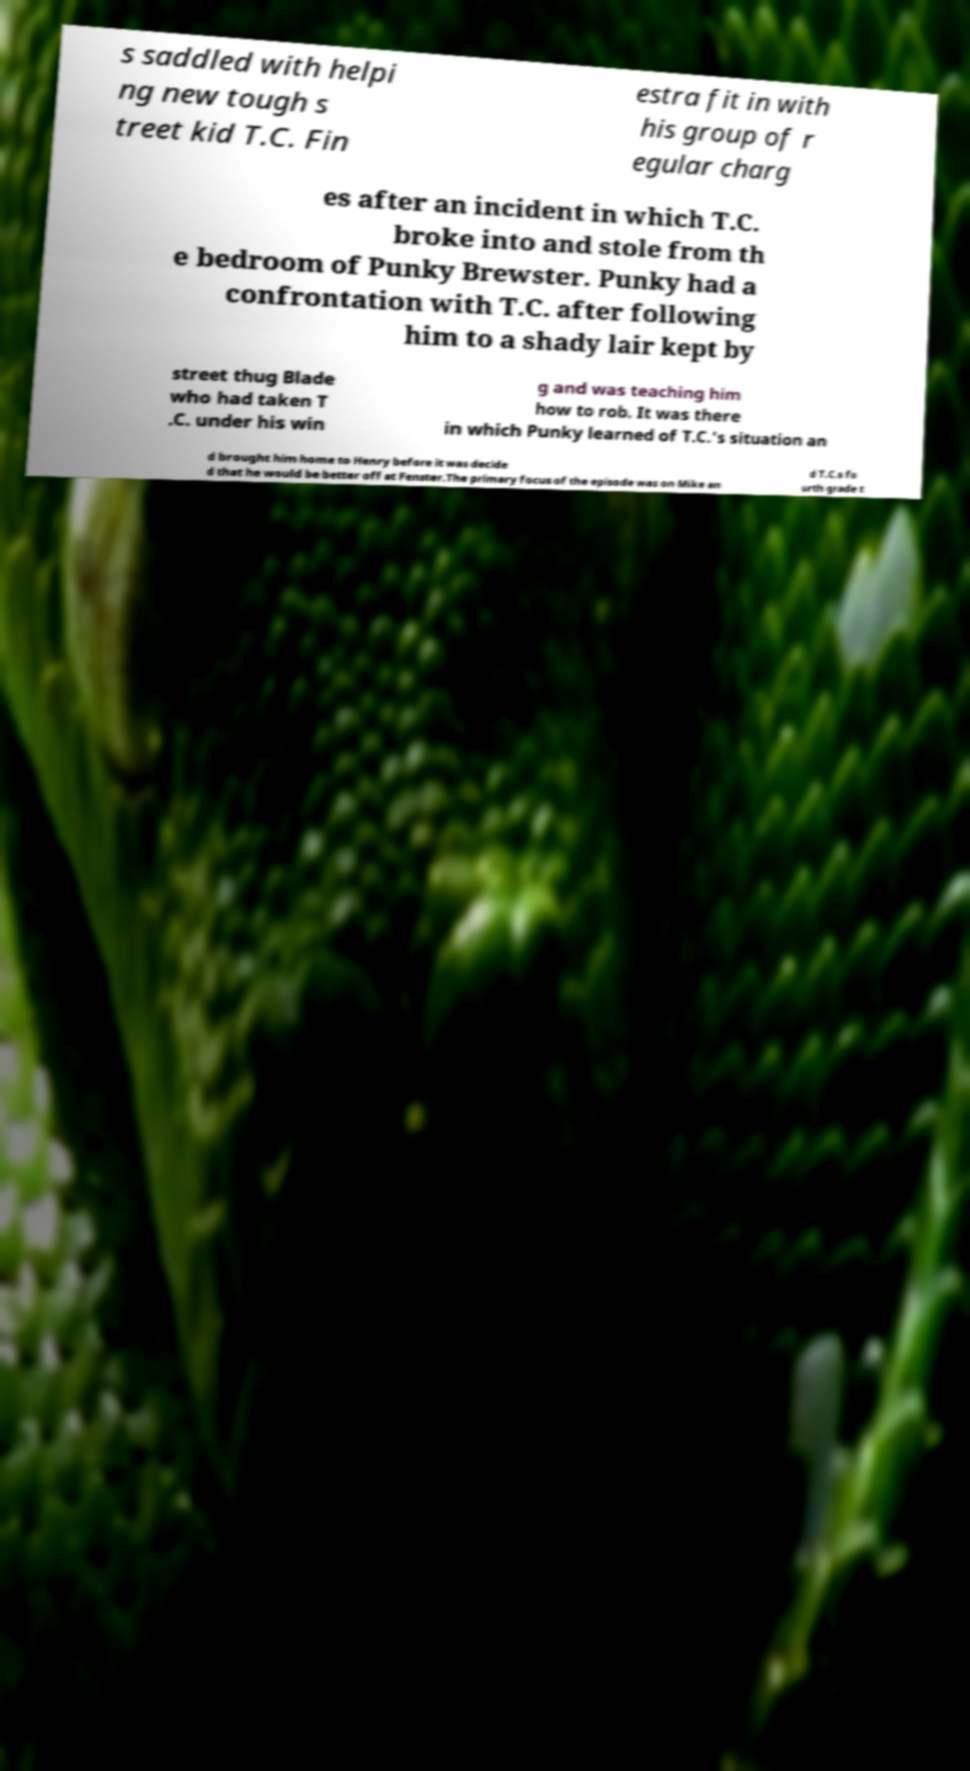Please read and relay the text visible in this image. What does it say? s saddled with helpi ng new tough s treet kid T.C. Fin estra fit in with his group of r egular charg es after an incident in which T.C. broke into and stole from th e bedroom of Punky Brewster. Punky had a confrontation with T.C. after following him to a shady lair kept by street thug Blade who had taken T .C. under his win g and was teaching him how to rob. It was there in which Punky learned of T.C.'s situation an d brought him home to Henry before it was decide d that he would be better off at Fenster.The primary focus of the episode was on Mike an d T.C.s fo urth grade t 